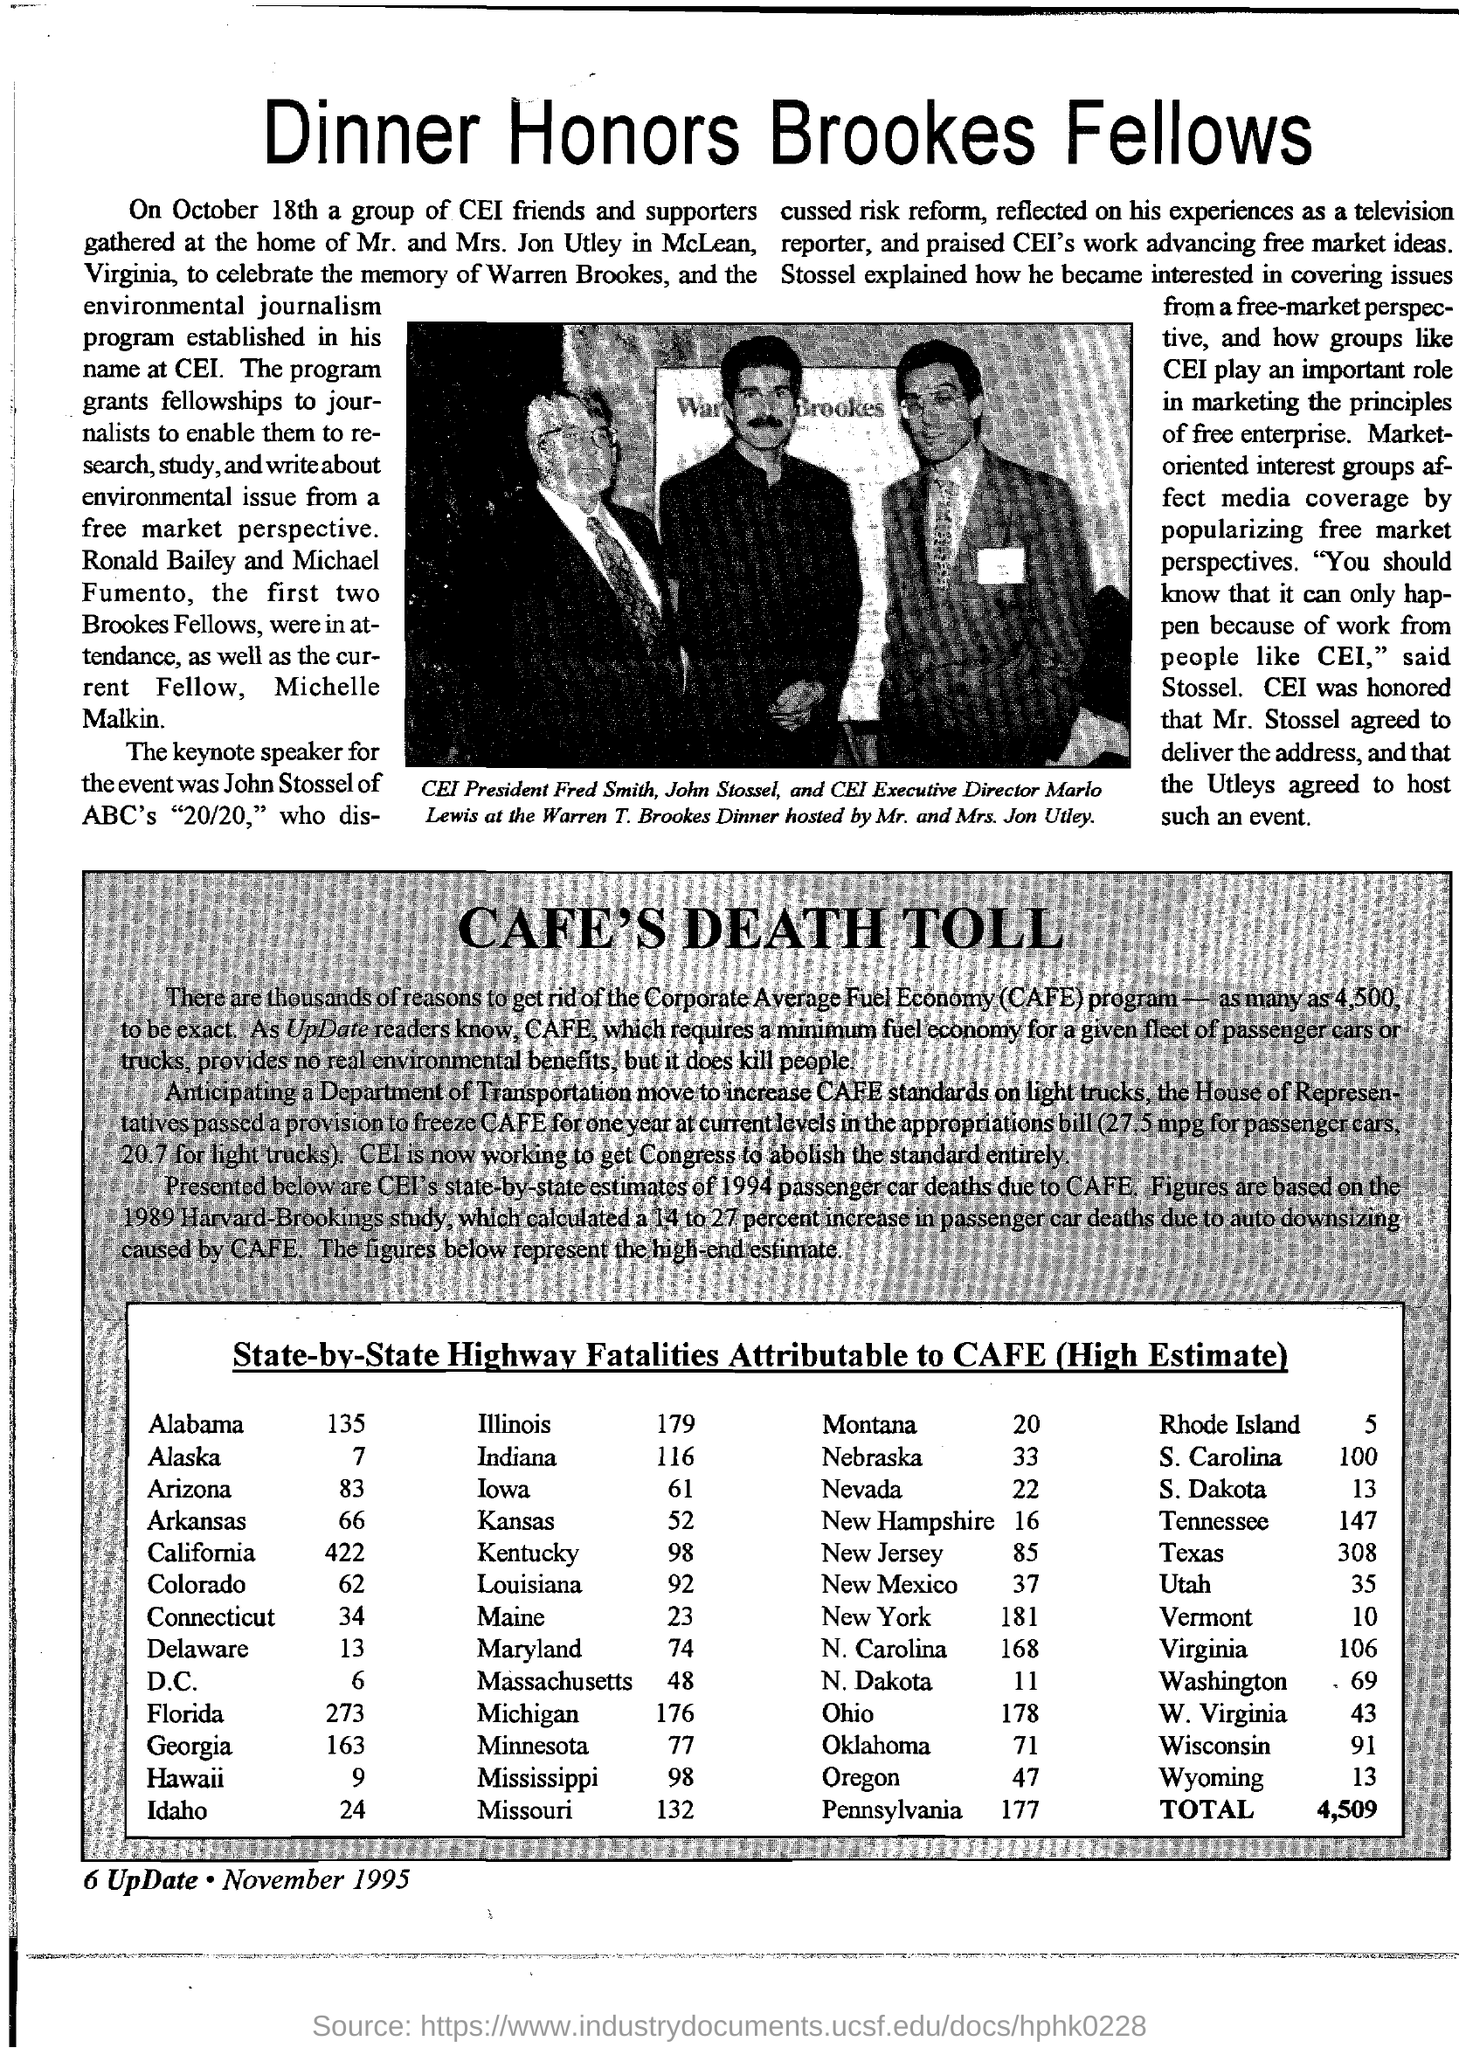What is the title of the document?
Your answer should be compact. Dinner Honors Brookes Fellows. Who is the president of CEI?
Your answer should be very brief. Fred Smith. Who is the CEI Executive Director?
Your answer should be compact. Marlo Lewis. 